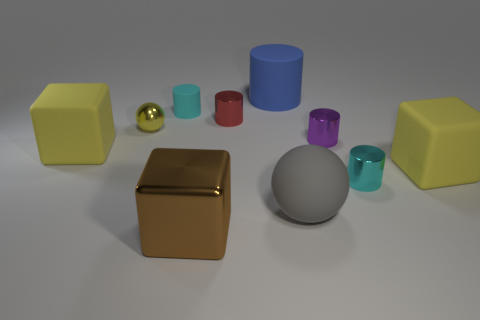How many things are either tiny shiny things left of the blue matte cylinder or large objects on the left side of the big gray rubber thing?
Your response must be concise. 5. Is there any other thing of the same color as the large matte cylinder?
Your answer should be compact. No. There is a big rubber object behind the small cyan object that is left of the tiny cyan cylinder to the right of the purple cylinder; what color is it?
Offer a terse response. Blue. There is a shiny thing in front of the cyan cylinder to the right of the gray matte thing; how big is it?
Offer a terse response. Large. What is the material of the block that is to the left of the cyan metallic thing and right of the tiny yellow object?
Your answer should be compact. Metal. Is the size of the red cylinder the same as the matte cylinder that is in front of the big matte cylinder?
Provide a succinct answer. Yes. Are there any large brown matte cylinders?
Your answer should be very brief. No. There is a small red thing that is the same shape as the small purple thing; what is its material?
Offer a terse response. Metal. What is the size of the cyan object that is behind the tiny cyan object to the right of the brown metallic block that is in front of the yellow ball?
Your response must be concise. Small. Are there any tiny red cylinders on the left side of the large brown block?
Give a very brief answer. No. 